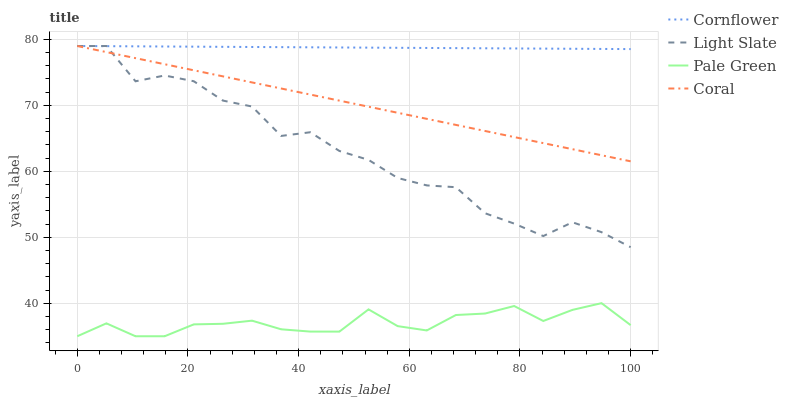Does Pale Green have the minimum area under the curve?
Answer yes or no. Yes. Does Cornflower have the maximum area under the curve?
Answer yes or no. Yes. Does Coral have the minimum area under the curve?
Answer yes or no. No. Does Coral have the maximum area under the curve?
Answer yes or no. No. Is Coral the smoothest?
Answer yes or no. Yes. Is Light Slate the roughest?
Answer yes or no. Yes. Is Cornflower the smoothest?
Answer yes or no. No. Is Cornflower the roughest?
Answer yes or no. No. Does Pale Green have the lowest value?
Answer yes or no. Yes. Does Coral have the lowest value?
Answer yes or no. No. Does Coral have the highest value?
Answer yes or no. Yes. Does Pale Green have the highest value?
Answer yes or no. No. Is Pale Green less than Light Slate?
Answer yes or no. Yes. Is Coral greater than Pale Green?
Answer yes or no. Yes. Does Light Slate intersect Cornflower?
Answer yes or no. Yes. Is Light Slate less than Cornflower?
Answer yes or no. No. Is Light Slate greater than Cornflower?
Answer yes or no. No. Does Pale Green intersect Light Slate?
Answer yes or no. No. 